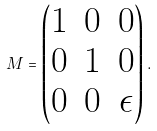Convert formula to latex. <formula><loc_0><loc_0><loc_500><loc_500>M = \begin{pmatrix} 1 & 0 & 0 \\ 0 & 1 & 0 \\ 0 & 0 & \epsilon \end{pmatrix} .</formula> 